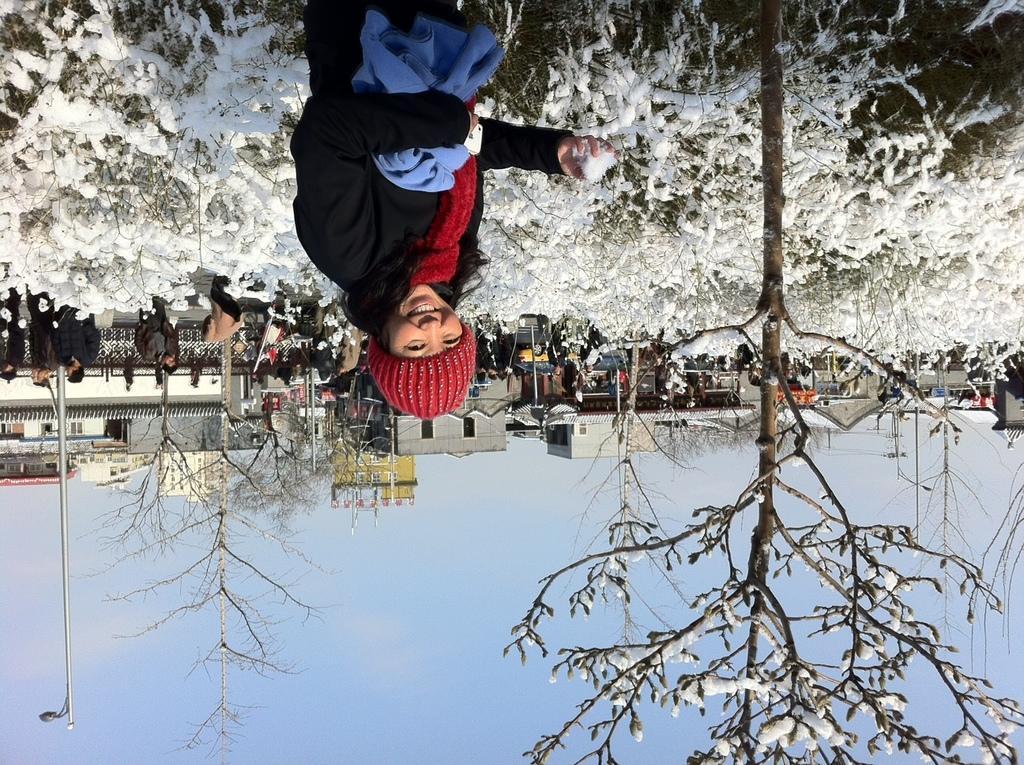Can you describe this image briefly? In the picture we can see a woman standing near the plants and she is smiling and on the plants we can see a snow and far away from it, we can see some houses, buildings, poles and behind it we can see a sky. 